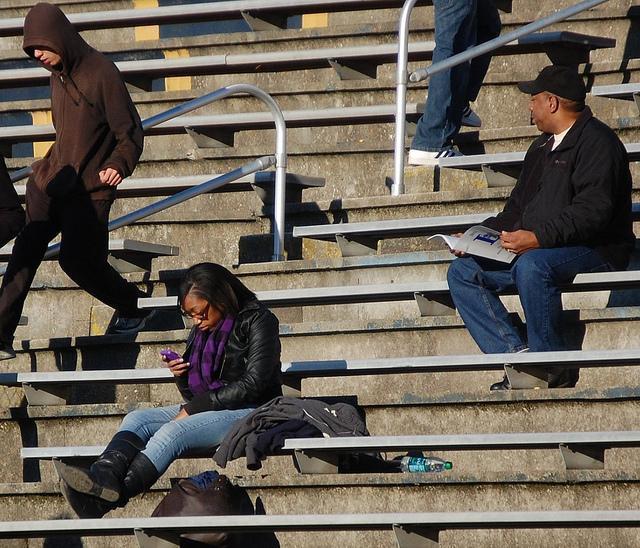What are the people sitting on?
From the following set of four choices, select the accurate answer to respond to the question.
Options: Bleachers, beach, beds, chairs. Bleachers. 